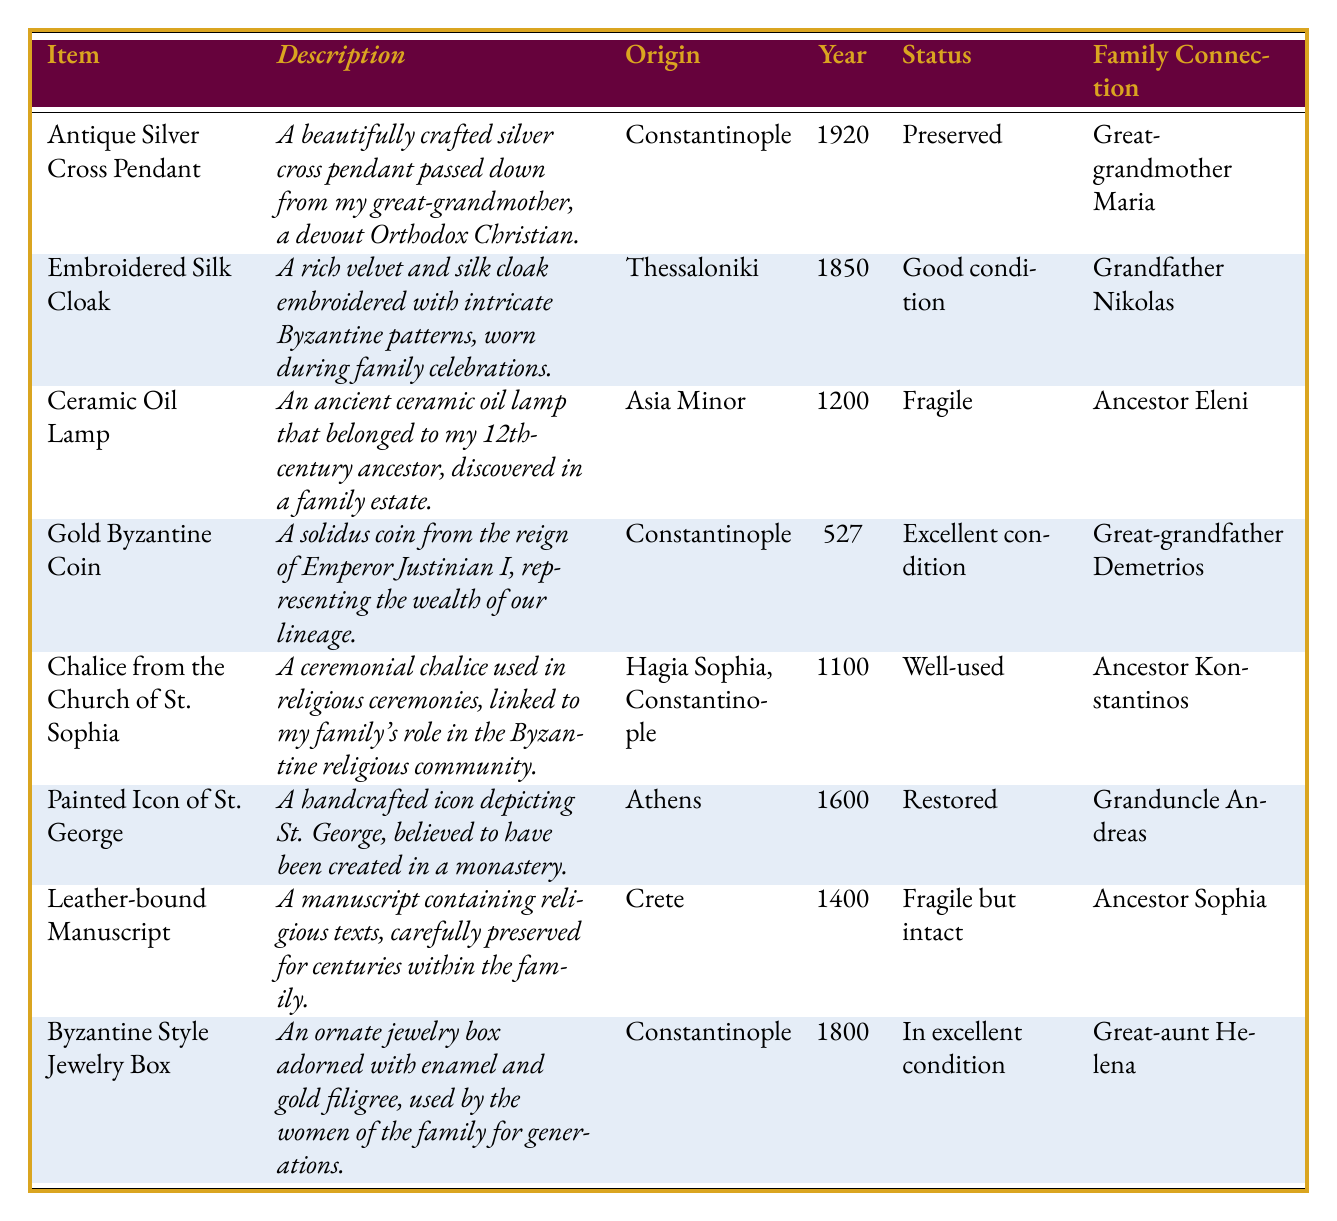What is the description of the antique silver cross pendant? The description of the antique silver cross pendant is mentioned in the table as "A beautifully crafted silver cross pendant passed down from my great-grandmother, a devout Orthodox Christian."
Answer: A beautifully crafted silver cross pendant passed down from my great-grandmother, a devout Orthodox Christian What is the origin of the ceramic oil lamp? The origin of the ceramic oil lamp is specified in the table as "Asia Minor."
Answer: Asia Minor Which item was acquired in the year 1800? By checking the year acquired column, the item listed for the year 1800 is the "Byzantine Style Jewelry Box."
Answer: Byzantine Style Jewelry Box Who is connected to the famous chalice from the Church of St. Sophia? The family connection for the chalice from the Church of St. Sophia is "Ancestor Konstantinos," as shown in the family connection column.
Answer: Ancestor Konstantinos How many items in the inventory are in excellent condition? By reviewing the status column, three items (Gold Byzantine Coin, Byzantine Style Jewelry Box) are noted as being in excellent condition.
Answer: 2 Was the embroidered silk cloak used in family celebrations? Yes, the description of the embroidered silk cloak indicates it was "worn during family celebrations."
Answer: Yes Among the listed heirlooms, which is the oldest item and what is its year acquired? The oldest item in the inventory is the "Gold Byzantine Coin," acquired in the year 527. This can be identified by comparing the years across all items.
Answer: Gold Byzantine Coin, 527 What is the difference in the years acquired between the ceramic oil lamp and the painted icon of St. George? The ceramic oil lamp was acquired in 1200 and the painted icon of St. George was acquired in 1600. The difference is calculated as 1600 - 1200 = 400 years.
Answer: 400 Which item is in fragile condition and what is the family connection to it? The item in fragile condition is the "Leather-bound Manuscript," and the family connection to it is "Ancestor Sophia," according to the table.
Answer: Leather-bound Manuscript, Ancestor Sophia Are all items that originated from Constantinople in good condition? No, not all items from Constantinople are in good condition. The "Antique Silver Cross Pendant" is preserved, but the condition of the "Chalice from the Church of St. Sophia" is "well-used."
Answer: No What can you conclude about the condition of the embroidered silk cloak compared to the leather-bound manuscript? The embroidered silk cloak is in "good condition," while the leather-bound manuscript is "fragile but intact." Therefore, the embroidered silk cloak is in better condition compared to the leather-bound manuscript.
Answer: The embroidered silk cloak is in better condition 